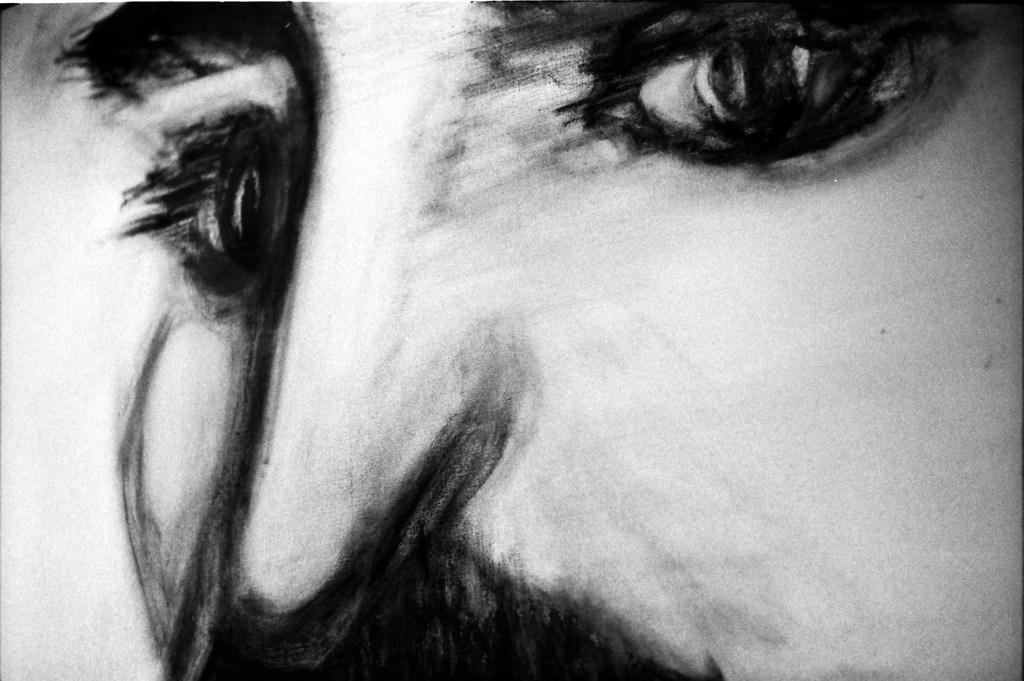What is depicted in the image? There is a drawing of a person's face in the image. What type of vase is being used to hold the soap in the image? There is no vase or soap present in the image; it only features a drawing of a person's face. 